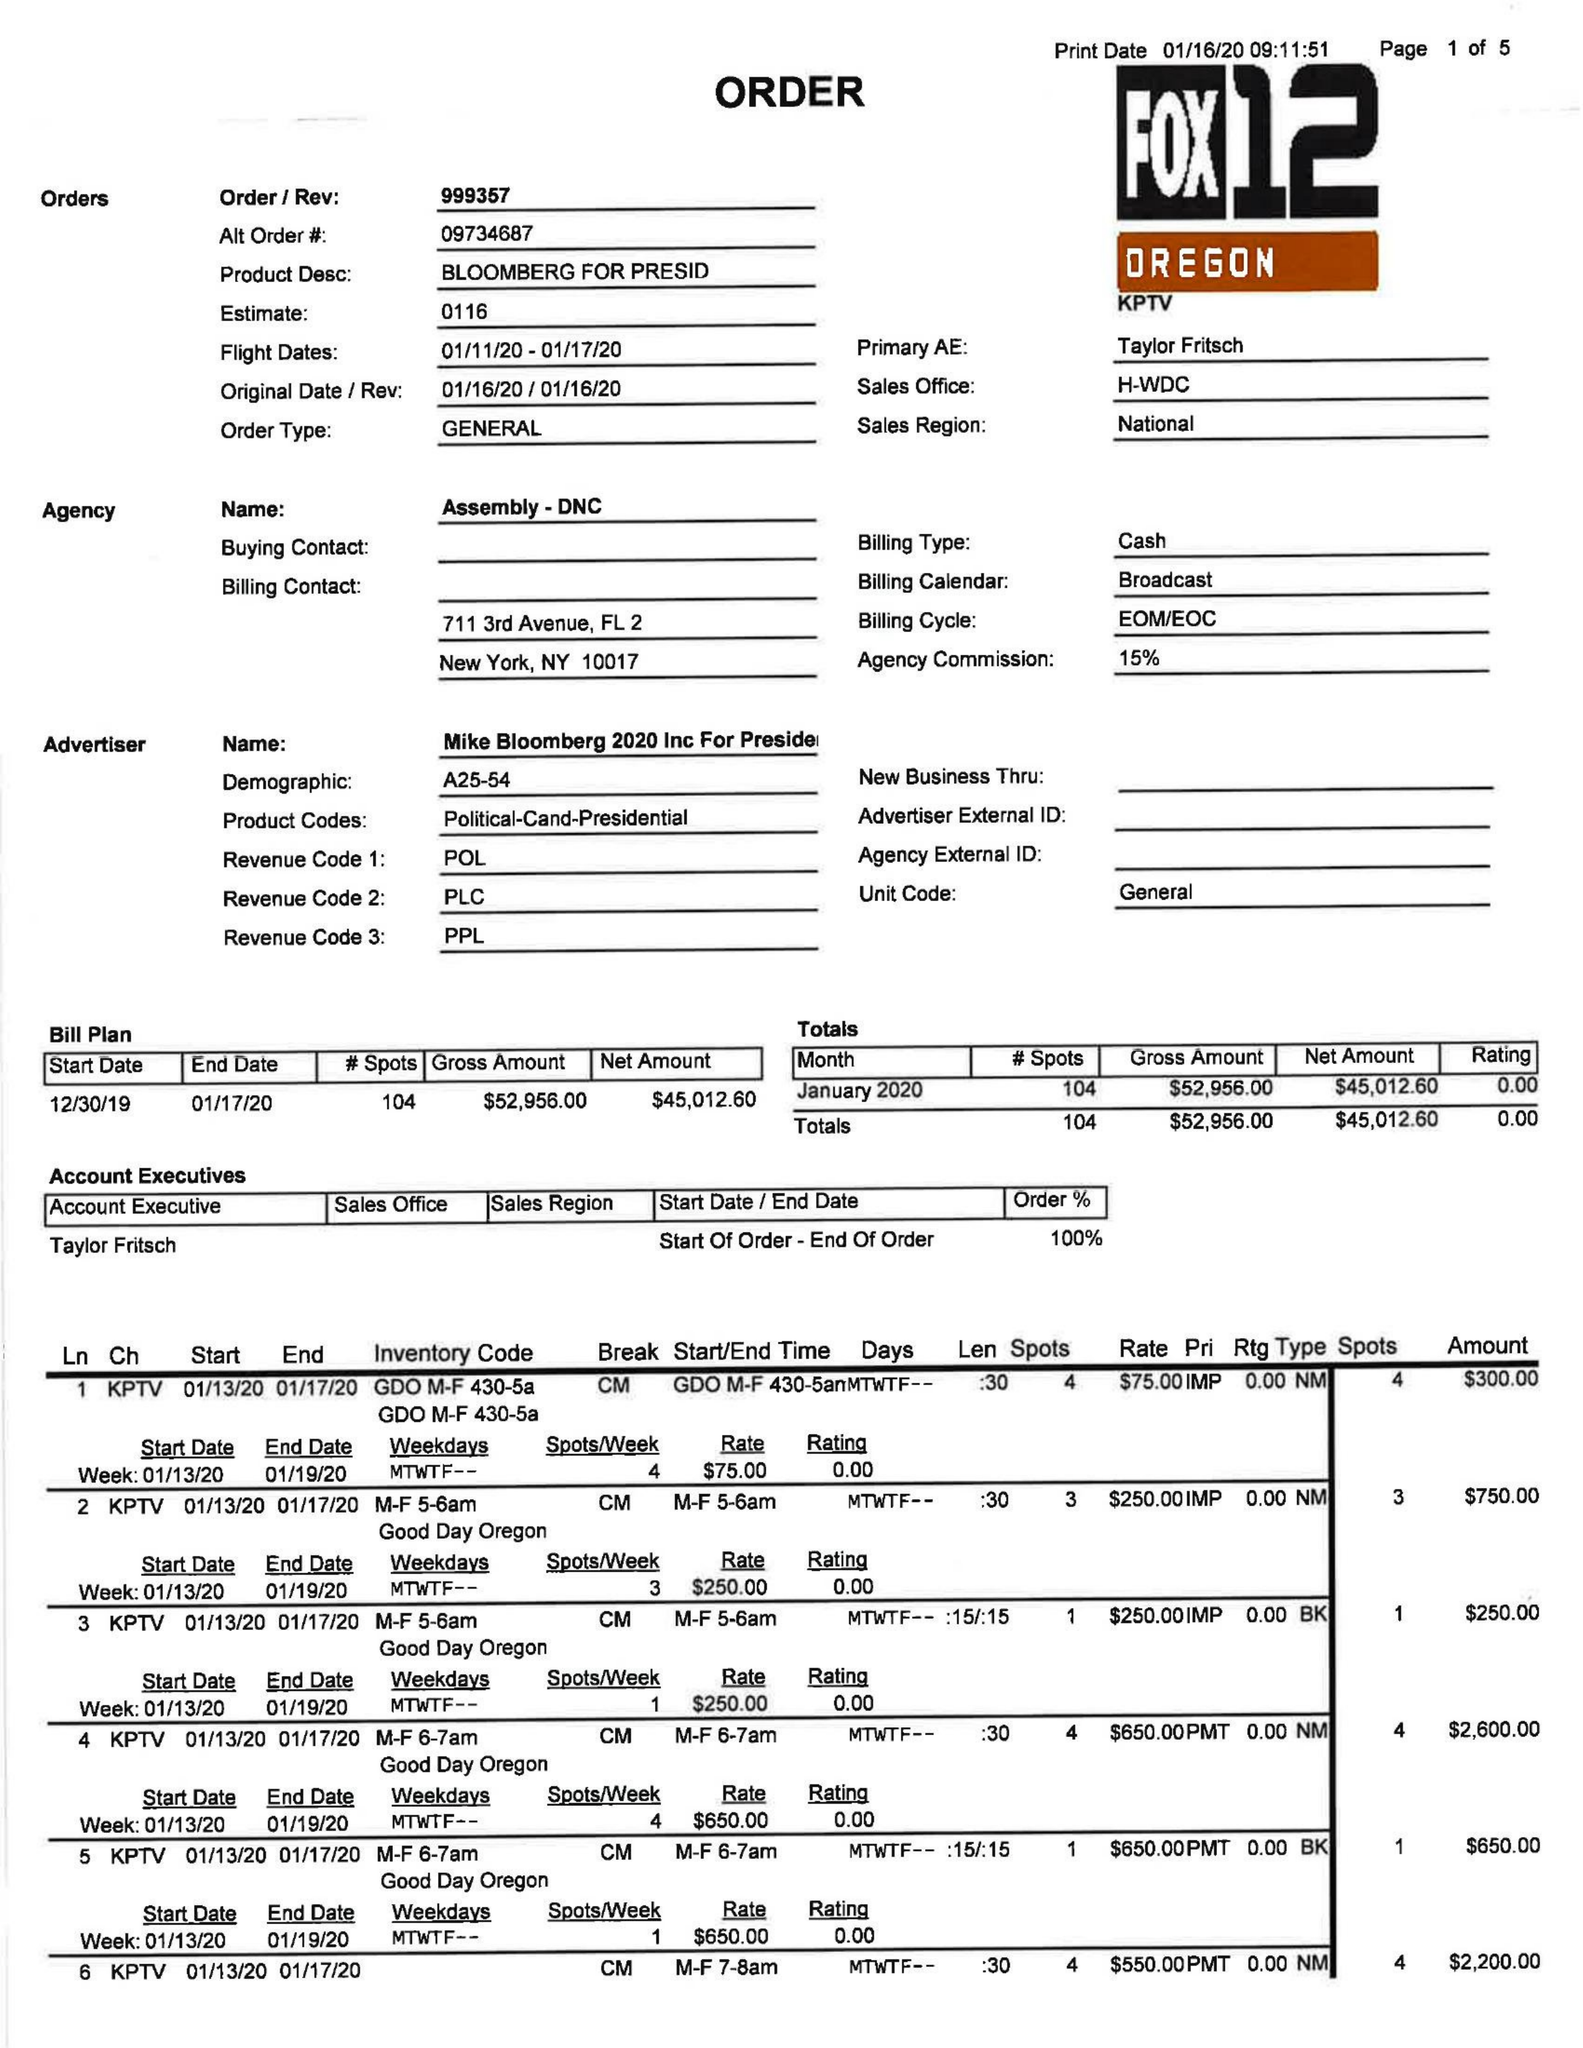What is the value for the flight_to?
Answer the question using a single word or phrase. 01/17/20 